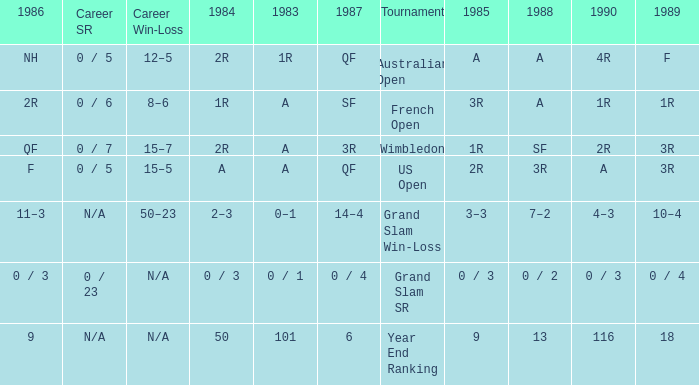In 1983 what is the tournament that is 0 / 1? Grand Slam SR. 